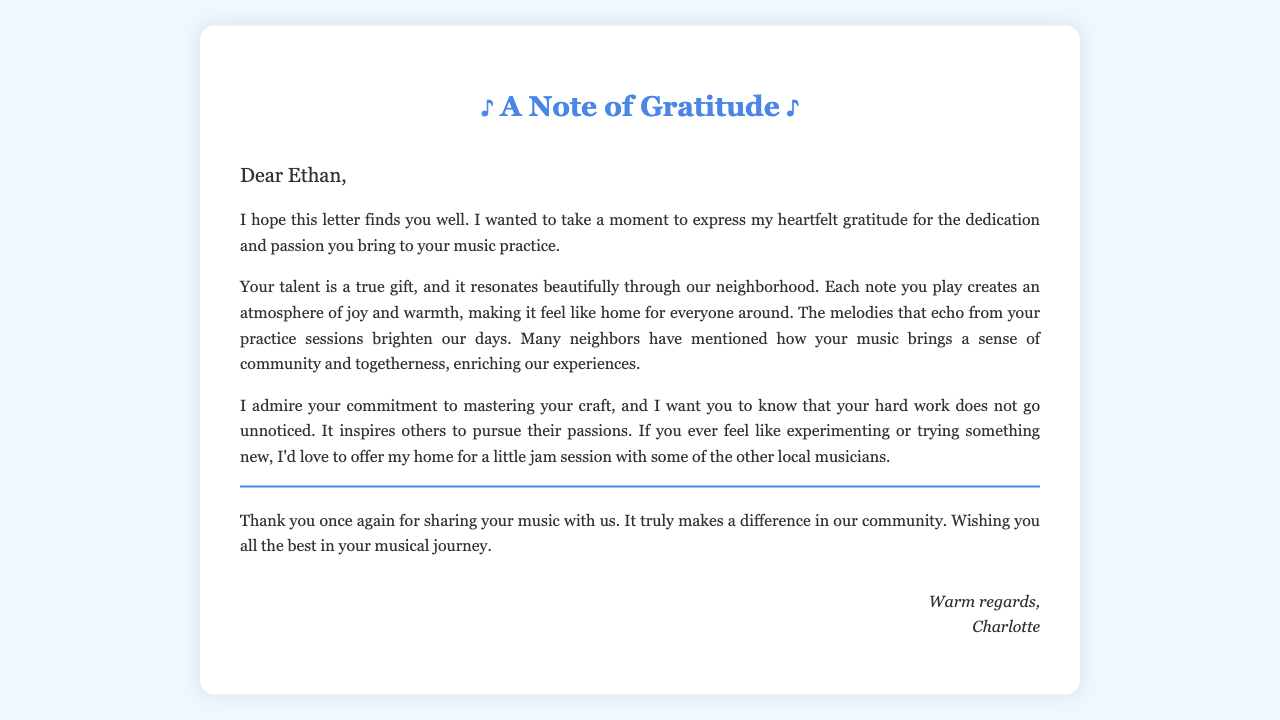What is the recipient's name? The letter is addressed to Ethan, which is mentioned in the greeting.
Answer: Ethan Who is the author of the letter? The letter is signed by Charlotte, indicating she is the author.
Answer: Charlotte What is the primary theme of the letter? The letter expresses gratitude for Ethan's dedication to his music and its impact on the neighborhood.
Answer: Gratitude What type of session does the author offer to Ethan? The letter mentions a jam session, indicating a casual music practice with others.
Answer: Jam session How does the author describe Ethan's talent? The author describes Ethan's talent as a "true gift," indicating it is special and valued.
Answer: True gift What effect does Ethan's music have on the community? The author states that Ethan's music creates "an atmosphere of joy and warmth," highlighting its positive influence.
Answer: Joy and warmth What does the author admire about Ethan? The author admires Ethan's "commitment to mastering your craft," which reflects respect for his dedication.
Answer: Commitment What specific invitation does the author extend to Ethan? The author extends an invitation to try something new at her home, indicating openness for collaboration.
Answer: Offer my home What is the overall tone of the letter? The letter conveys a warm and appreciative tone towards Ethan and his music.
Answer: Warm and appreciative 